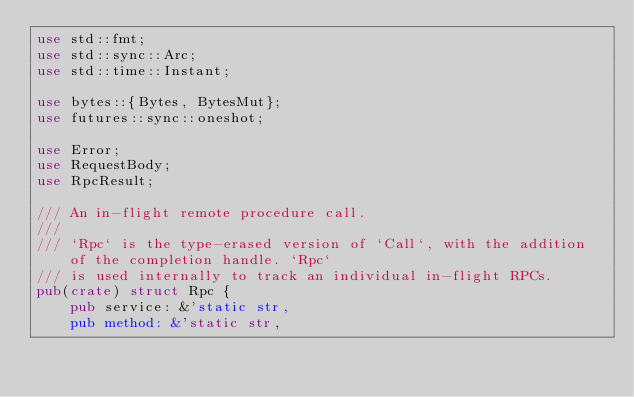Convert code to text. <code><loc_0><loc_0><loc_500><loc_500><_Rust_>use std::fmt;
use std::sync::Arc;
use std::time::Instant;

use bytes::{Bytes, BytesMut};
use futures::sync::oneshot;

use Error;
use RequestBody;
use RpcResult;

/// An in-flight remote procedure call.
///
/// `Rpc` is the type-erased version of `Call`, with the addition of the completion handle. `Rpc`
/// is used internally to track an individual in-flight RPCs.
pub(crate) struct Rpc {
    pub service: &'static str,
    pub method: &'static str,</code> 